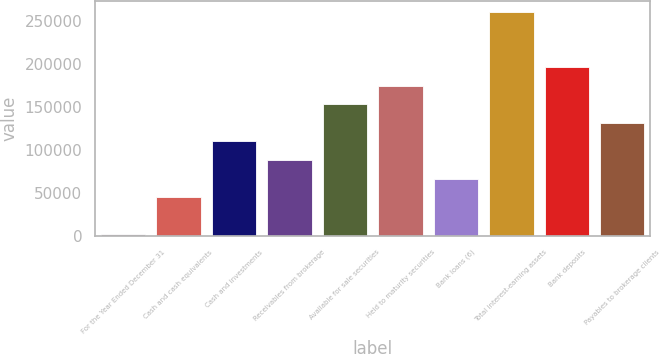Convert chart. <chart><loc_0><loc_0><loc_500><loc_500><bar_chart><fcel>For the Year Ended December 31<fcel>Cash and cash equivalents<fcel>Cash and investments<fcel>Receivables from brokerage<fcel>Available for sale securities<fcel>Held to maturity securities<fcel>Bank loans (6)<fcel>Total interest-earning assets<fcel>Bank deposits<fcel>Payables to brokerage clients<nl><fcel>2017<fcel>45156.2<fcel>109865<fcel>88295.4<fcel>153004<fcel>174574<fcel>66725.8<fcel>260852<fcel>196143<fcel>131435<nl></chart> 